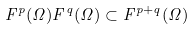Convert formula to latex. <formula><loc_0><loc_0><loc_500><loc_500>F ^ { p } ( \Omega ) F ^ { q } ( \Omega ) \subset F ^ { p + q } ( \Omega )</formula> 